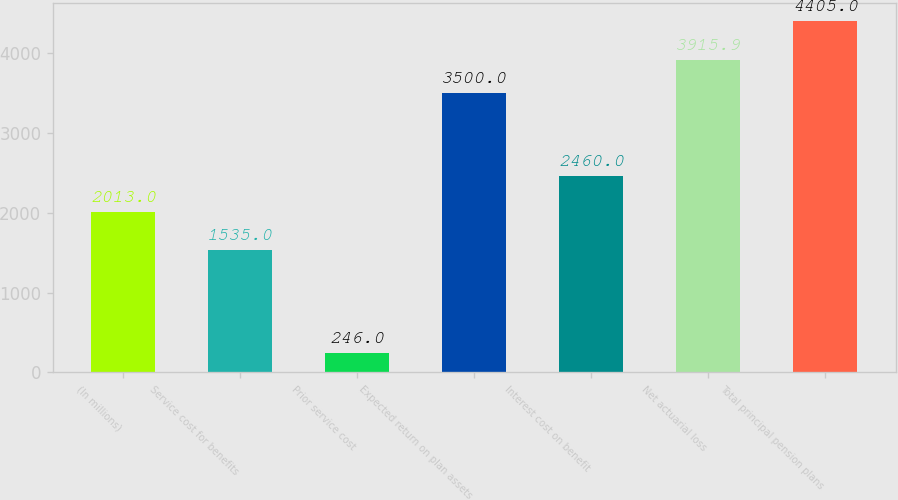Convert chart. <chart><loc_0><loc_0><loc_500><loc_500><bar_chart><fcel>(In millions)<fcel>Service cost for benefits<fcel>Prior service cost<fcel>Expected return on plan assets<fcel>Interest cost on benefit<fcel>Net actuarial loss<fcel>Total principal pension plans<nl><fcel>2013<fcel>1535<fcel>246<fcel>3500<fcel>2460<fcel>3915.9<fcel>4405<nl></chart> 